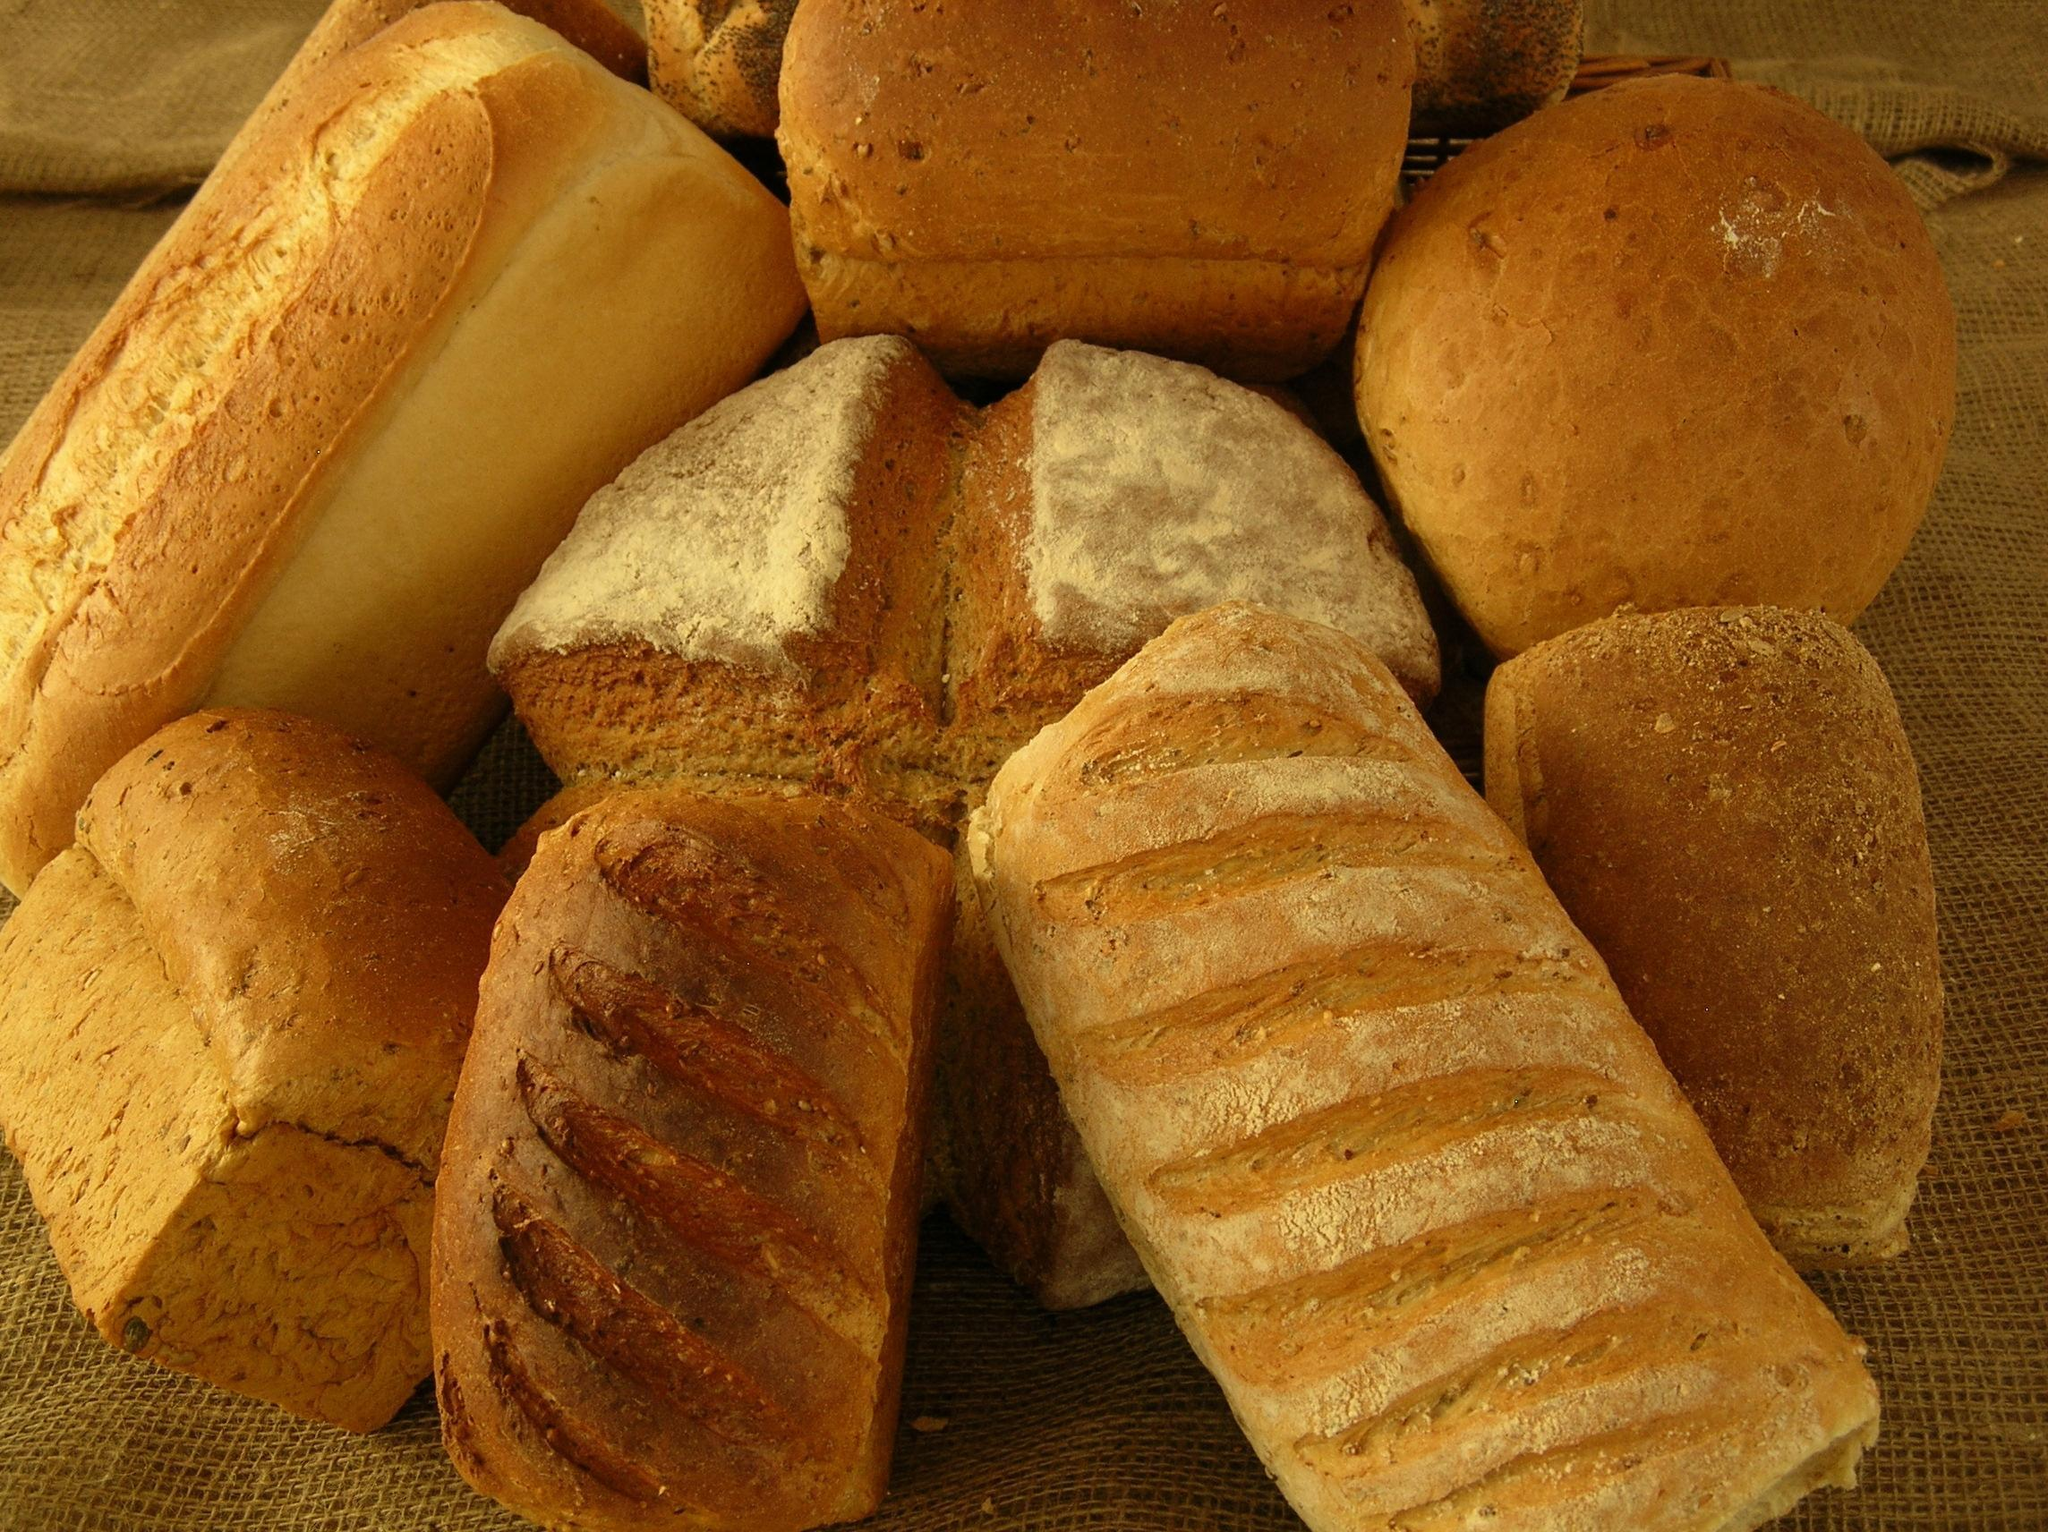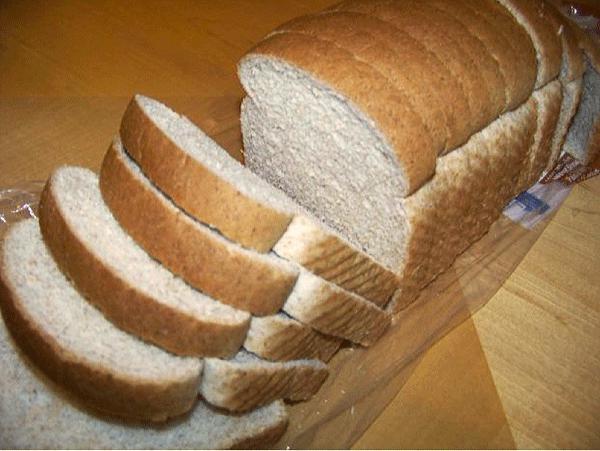The first image is the image on the left, the second image is the image on the right. For the images shown, is this caption "One image shows a bread loaf with at least one cut slice on a cutting board, and the other image includes multiple whole loaves with diagonal slash marks on top." true? Answer yes or no. Yes. The first image is the image on the left, the second image is the image on the right. For the images shown, is this caption "In one image, two or more loaves of bread feature diagonal designs that were cut into the top of the dough prior to baking." true? Answer yes or no. Yes. 